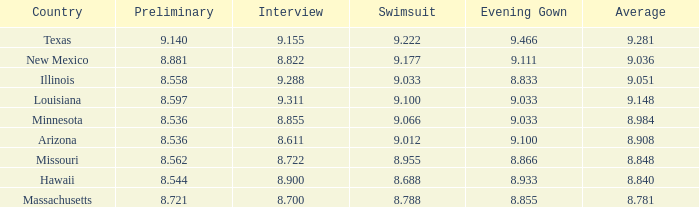What was the swimsuit score for the country with the average score of 8.848? 8.955. 